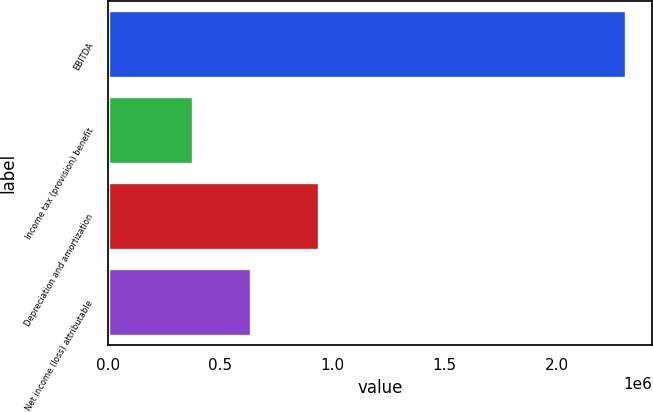Convert chart to OTSL. <chart><loc_0><loc_0><loc_500><loc_500><bar_chart><fcel>EBITDA<fcel>Income tax (provision) benefit<fcel>Depreciation and amortization<fcel>Net income (loss) attributable<nl><fcel>2.3114e+06<fcel>377429<fcel>940033<fcel>635545<nl></chart> 